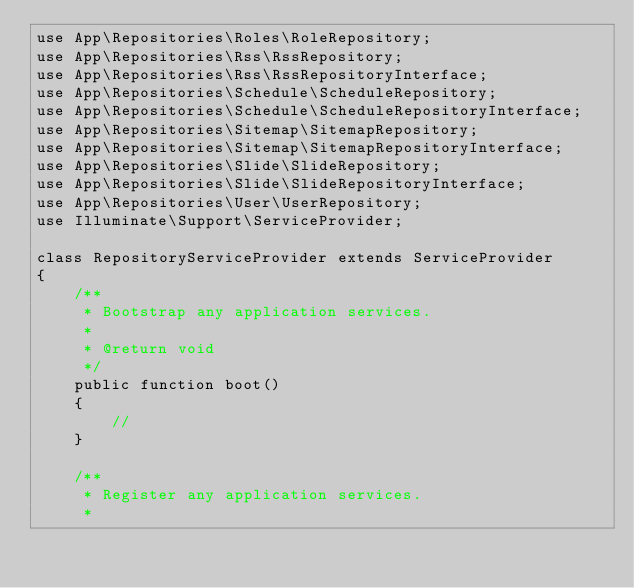<code> <loc_0><loc_0><loc_500><loc_500><_PHP_>use App\Repositories\Roles\RoleRepository;
use App\Repositories\Rss\RssRepository;
use App\Repositories\Rss\RssRepositoryInterface;
use App\Repositories\Schedule\ScheduleRepository;
use App\Repositories\Schedule\ScheduleRepositoryInterface;
use App\Repositories\Sitemap\SitemapRepository;
use App\Repositories\Sitemap\SitemapRepositoryInterface;
use App\Repositories\Slide\SlideRepository;
use App\Repositories\Slide\SlideRepositoryInterface;
use App\Repositories\User\UserRepository;
use Illuminate\Support\ServiceProvider;

class RepositoryServiceProvider extends ServiceProvider
{
    /**
     * Bootstrap any application services.
     *
     * @return void
     */
    public function boot()
    {
        //
    }

    /**
     * Register any application services.
     *</code> 